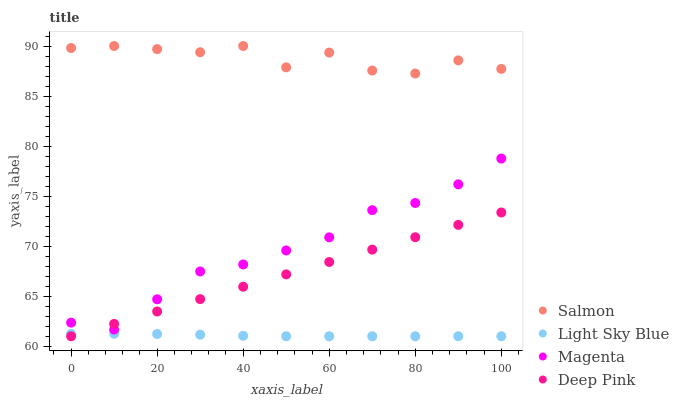Does Light Sky Blue have the minimum area under the curve?
Answer yes or no. Yes. Does Salmon have the maximum area under the curve?
Answer yes or no. Yes. Does Salmon have the minimum area under the curve?
Answer yes or no. No. Does Light Sky Blue have the maximum area under the curve?
Answer yes or no. No. Is Deep Pink the smoothest?
Answer yes or no. Yes. Is Salmon the roughest?
Answer yes or no. Yes. Is Light Sky Blue the smoothest?
Answer yes or no. No. Is Light Sky Blue the roughest?
Answer yes or no. No. Does Light Sky Blue have the lowest value?
Answer yes or no. Yes. Does Salmon have the lowest value?
Answer yes or no. No. Does Salmon have the highest value?
Answer yes or no. Yes. Does Light Sky Blue have the highest value?
Answer yes or no. No. Is Magenta less than Salmon?
Answer yes or no. Yes. Is Salmon greater than Deep Pink?
Answer yes or no. Yes. Does Light Sky Blue intersect Deep Pink?
Answer yes or no. Yes. Is Light Sky Blue less than Deep Pink?
Answer yes or no. No. Is Light Sky Blue greater than Deep Pink?
Answer yes or no. No. Does Magenta intersect Salmon?
Answer yes or no. No. 